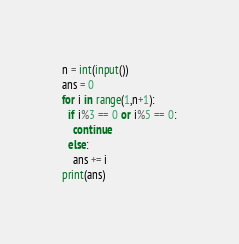<code> <loc_0><loc_0><loc_500><loc_500><_Python_>n = int(input())
ans = 0
for i in range(1,n+1):
  if i%3 == 0 or i%5 == 0:
    continue
  else:
    ans += i
print(ans)</code> 